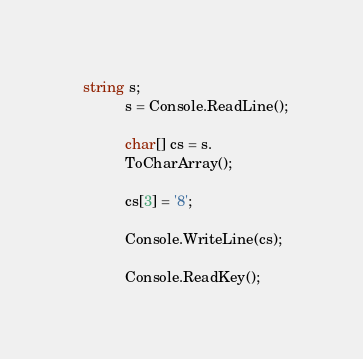Convert code to text. <code><loc_0><loc_0><loc_500><loc_500><_C#_>  string s;
            s = Console.ReadLine();

            char[] cs = s.
            ToCharArray();

            cs[3] = '8';

            Console.WriteLine(cs);

            Console.ReadKey();</code> 